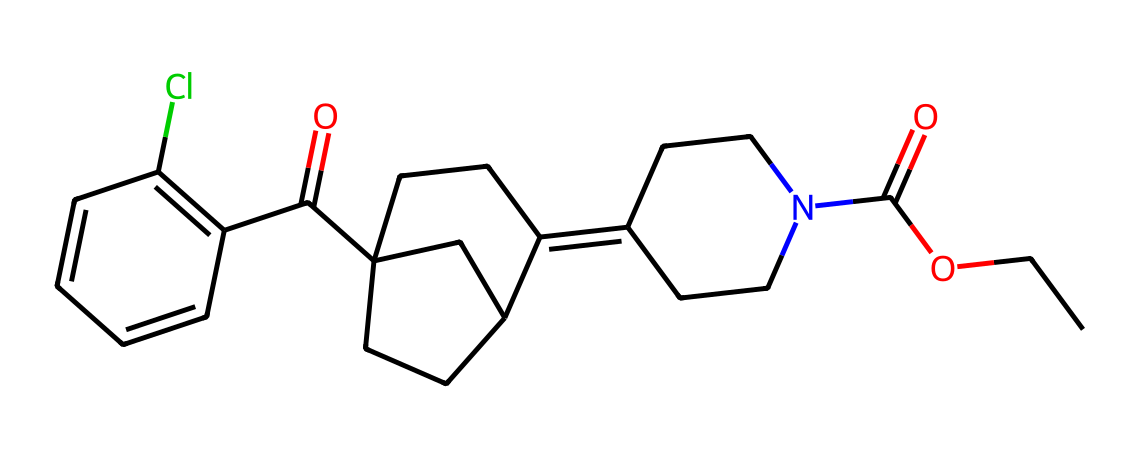What is the molecular formula of loratadine? To determine the molecular formula, we can analyze the atoms present in the SMILES representation. By counting the atoms represented, we find that there are 22 carbon (C) atoms, 23 hydrogen (H) atoms, 2 oxygen (O) atoms, and 1 nitrogen (N) atom. Thus, the molecular formula is C22H23ClN2O2.
Answer: C22H23ClN2O2 How many rings are present in the structure of loratadine? By examining the SMILES structure, we note the identifiers for rings (especially the numbers present that link atoms together). In this case, there are three rings that can be identified in the structure.
Answer: 3 What is the primary functional group in loratadine? The functional groups can usually be identified based on certain common structures such as amines, esters, or aromatic rings. In the case of loratadine, the ester functional group is prominent given the presence of the carbonyl oxygen attached to an alkyl chain.
Answer: ester How many double bonds can be found in this chemical structure? To count the double bonds, we need to review the connections in the SMILES representation, particularly looking for '=' indications. In this structure, there are a total of four double bonds.
Answer: 4 What element is represented by the 'Cl' in loratadine? In the molecular structure, 'Cl' denotes the presence of chlorine, a halogen. This is important for understanding the reactivity and properties of the compound.
Answer: chlorine Which part of the structure contributes to loratadine's classification as an antihistamine? Antihistamines are often characterized by specific structural features that allow them to block histamine receptors. Loratadine contains a diphenylmethane structure that is known to interact with these receptors, effectively categorizing it as an antihistamine.
Answer: diphenylmethane 